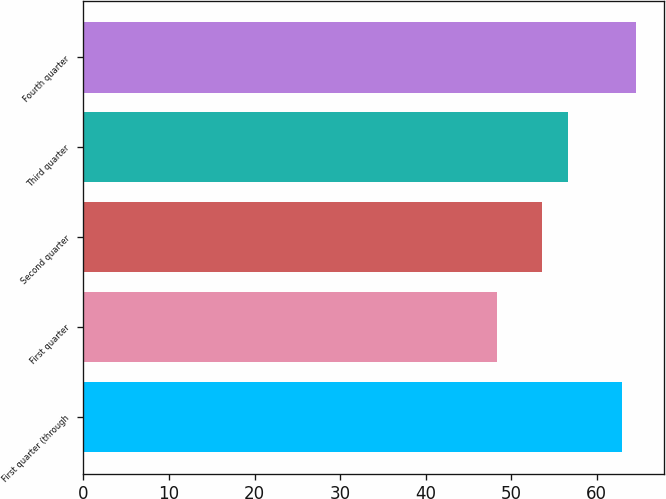Convert chart to OTSL. <chart><loc_0><loc_0><loc_500><loc_500><bar_chart><fcel>First quarter (through<fcel>First quarter<fcel>Second quarter<fcel>Third quarter<fcel>Fourth quarter<nl><fcel>62.93<fcel>48.33<fcel>53.64<fcel>56.66<fcel>64.61<nl></chart> 